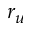Convert formula to latex. <formula><loc_0><loc_0><loc_500><loc_500>r _ { u }</formula> 